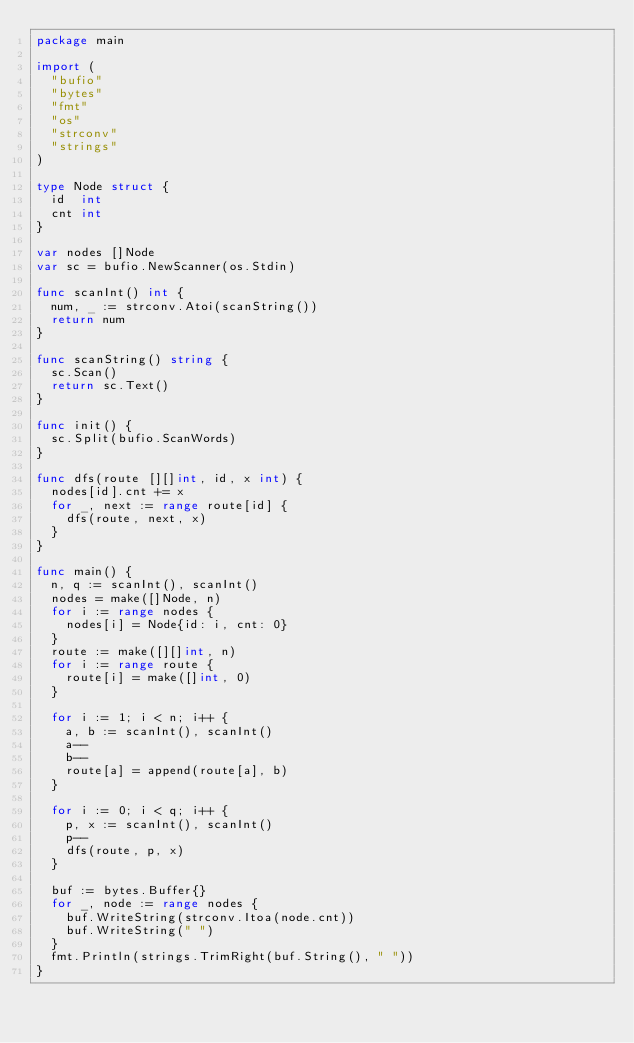<code> <loc_0><loc_0><loc_500><loc_500><_Go_>package main

import (
	"bufio"
	"bytes"
	"fmt"
	"os"
	"strconv"
	"strings"
)

type Node struct {
	id  int
	cnt int
}

var nodes []Node
var sc = bufio.NewScanner(os.Stdin)

func scanInt() int {
	num, _ := strconv.Atoi(scanString())
	return num
}

func scanString() string {
	sc.Scan()
	return sc.Text()
}

func init() {
	sc.Split(bufio.ScanWords)
}

func dfs(route [][]int, id, x int) {
	nodes[id].cnt += x
	for _, next := range route[id] {
		dfs(route, next, x)
	}
}

func main() {
	n, q := scanInt(), scanInt()
	nodes = make([]Node, n)
	for i := range nodes {
		nodes[i] = Node{id: i, cnt: 0}
	}
	route := make([][]int, n)
	for i := range route {
		route[i] = make([]int, 0)
	}

	for i := 1; i < n; i++ {
		a, b := scanInt(), scanInt()
		a--
		b--
		route[a] = append(route[a], b)
	}

	for i := 0; i < q; i++ {
		p, x := scanInt(), scanInt()
		p--
		dfs(route, p, x)
	}

	buf := bytes.Buffer{}
	for _, node := range nodes {
		buf.WriteString(strconv.Itoa(node.cnt))
		buf.WriteString(" ")
	}
	fmt.Println(strings.TrimRight(buf.String(), " "))
}
</code> 